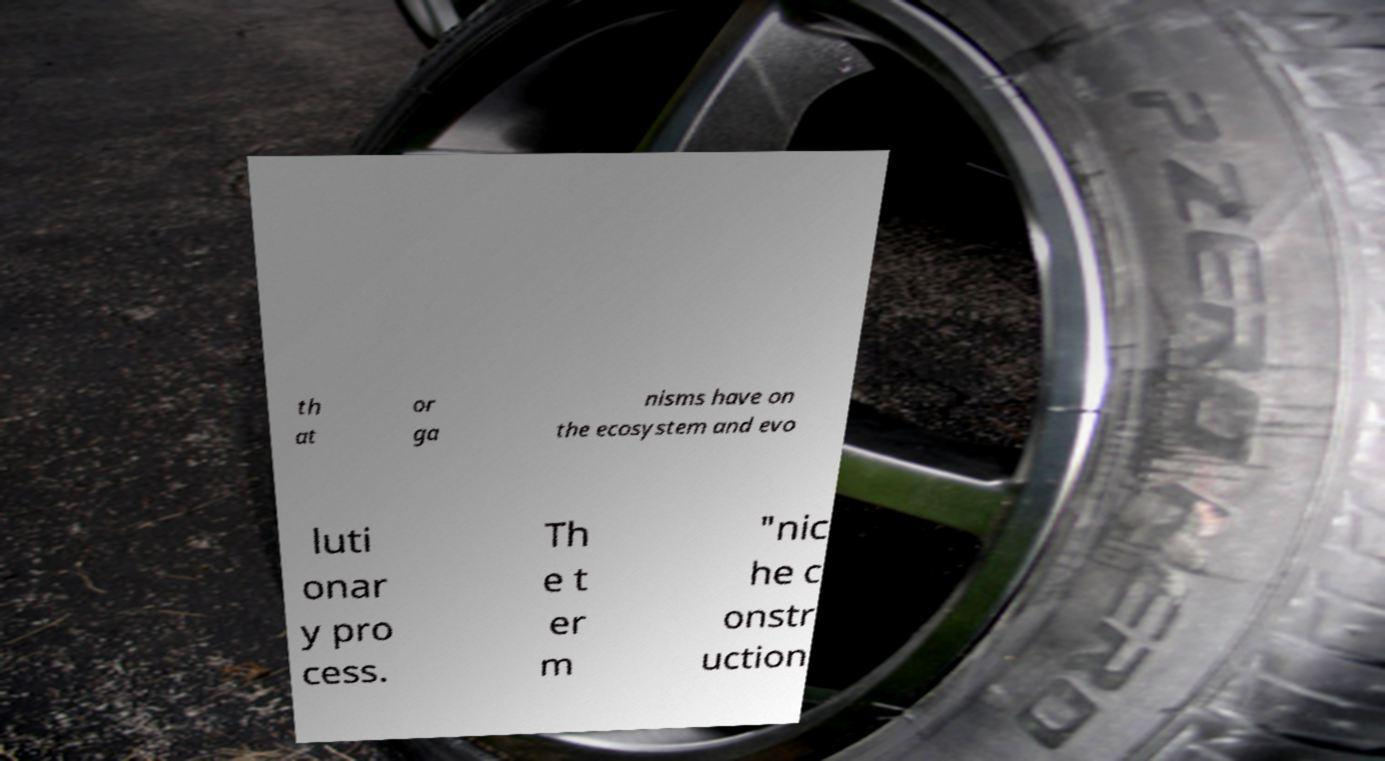Can you read and provide the text displayed in the image?This photo seems to have some interesting text. Can you extract and type it out for me? th at or ga nisms have on the ecosystem and evo luti onar y pro cess. Th e t er m "nic he c onstr uction 